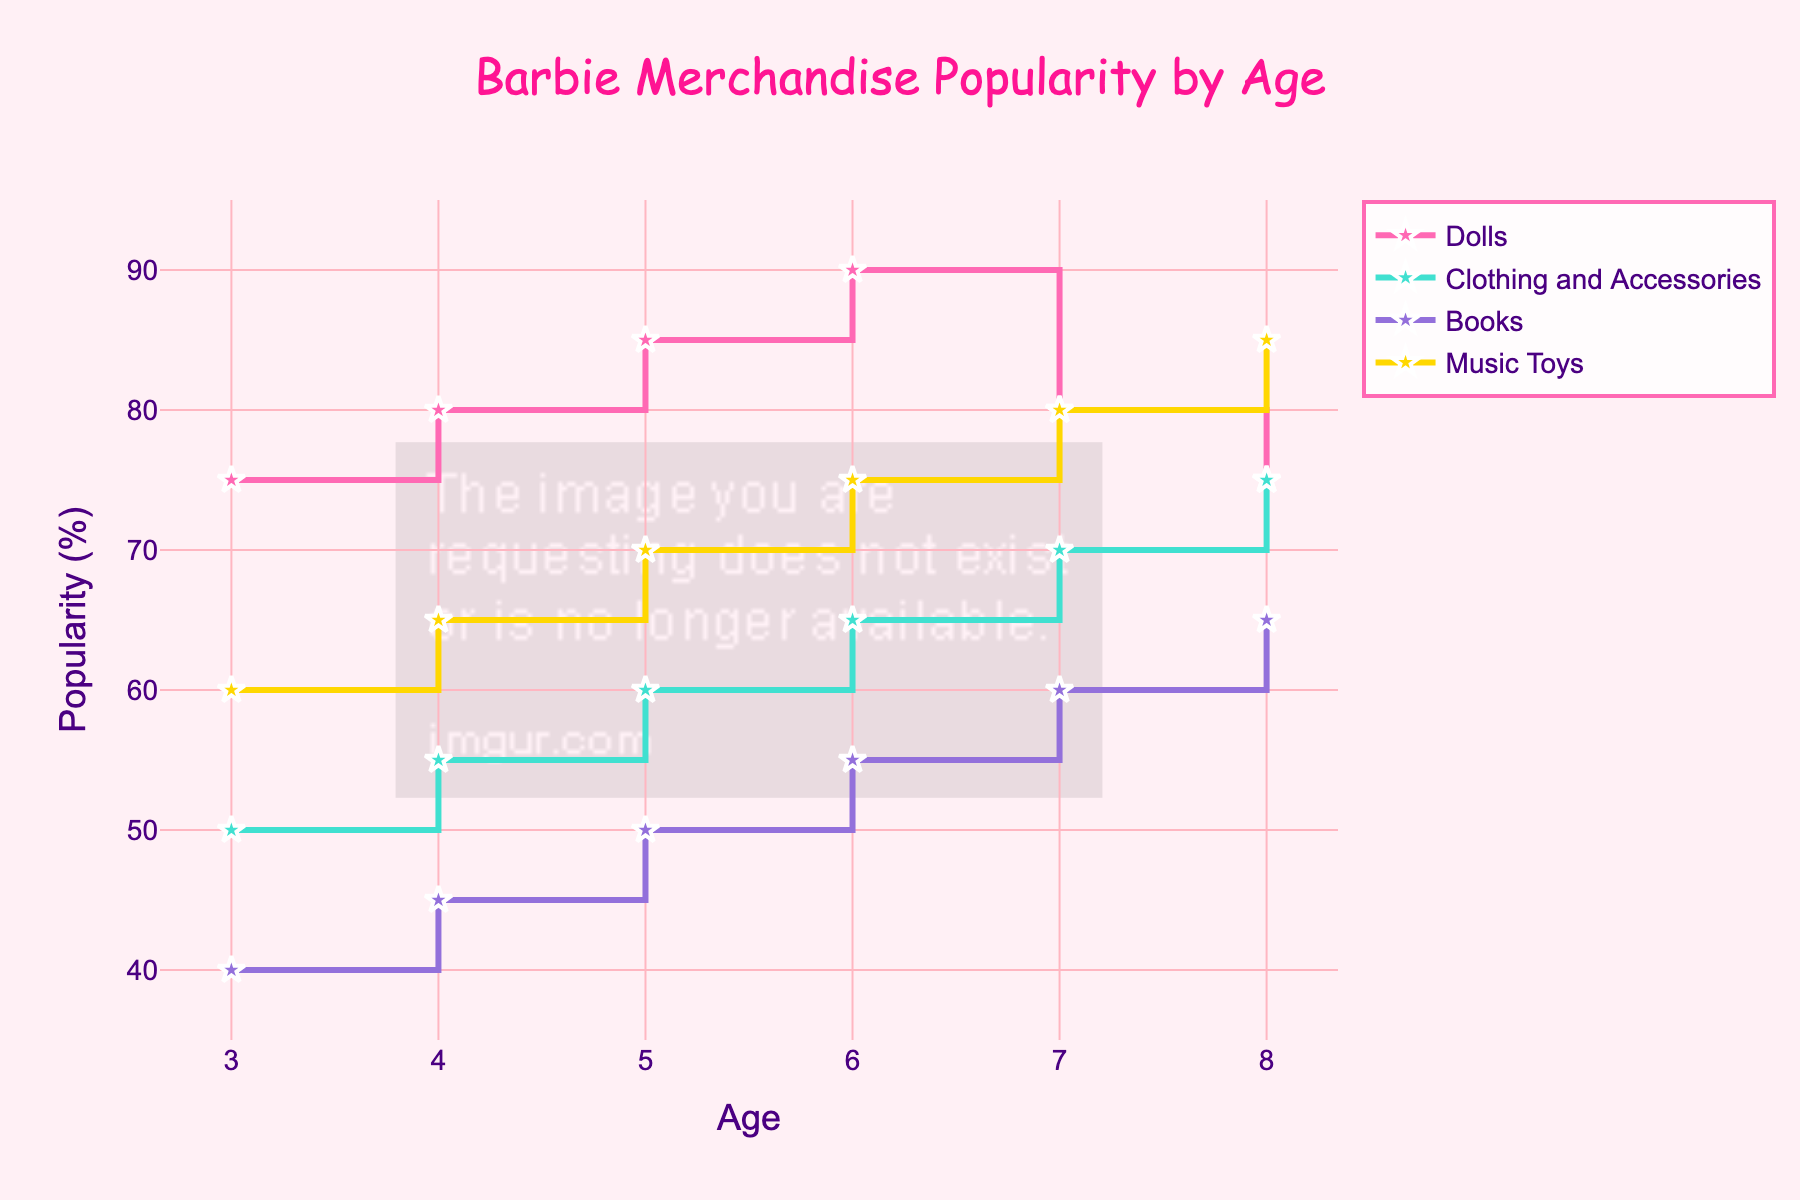what is the title of the figure? The title of the figure can be found at the top. It is usually the largest text and describes the main content of the plot.
Answer: Barbie Merchandise Popularity by Age What age group has the highest popularity for Barbie Dolls? The highest popularity for Barbie Dolls can be found by looking at the y-axis values for each age group and identifying the maximum percentage.
Answer: 6 years old Comparing 5 and 7-year-olds, which age group prefers Barbie books more? To compare the popularity of Barbie books between 5 and 7-year-olds, look at the y-values corresponding to 'Books' for ages 5 and 7. The group with the higher y-value prefers Barbie books more.
Answer: 7 years old How does the popularity of Music Toys for 4-year-olds compare to that for 8-year-olds? Check the y-axis values for the 'Music Toys' trace at ages 4 and 8. Compare these two values to see which age group has higher popularity.
Answer: 8-year-olds have higher popularity What is the average popularity of Clothing and Accessories across all age groups? Find the y-axis values for 'Clothing and Accessories' across all age groups (50, 55, 60, 65, 70, 75). Sum these values and divide by the number of data points (6) to get the average. (50 + 55 + 60 + 65 + 70 + 75) / 6 = 62.5
Answer: 62.5% What age group shows a decline in doll popularity from the previous age group? To identify the age group with a decline, compare the y-values of 'Dolls' for consecutive age groups and find where the value decreases.
Answer: 7 years old From ages 3 to 8, by how much does the popularity of Music Toys change? Find the difference in y-axis values for the 'Music Toys' trace between ages 3 and 8. Subtract the value at age 3 from the value at age 8. 85% - 60% = 25%
Answer: 25% Which type of Barbie merchandise is the least popular among 6-year-olds? Compare the y-axis values for all types of merchandise at age 6 and identify the smallest value.
Answer: Books 